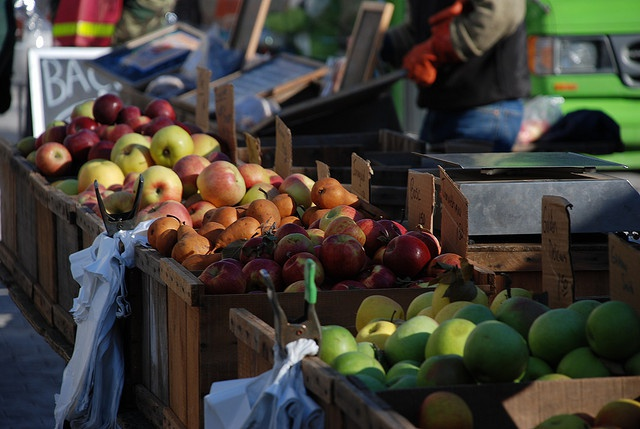Describe the objects in this image and their specific colors. I can see apple in teal, black, darkgreen, and maroon tones, people in teal, black, gray, and maroon tones, truck in teal, lightgreen, black, gray, and darkgreen tones, apple in teal, brown, tan, and maroon tones, and apple in teal, black, maroon, brown, and gray tones in this image. 